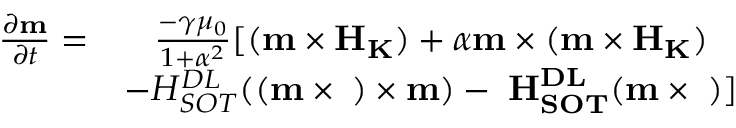Convert formula to latex. <formula><loc_0><loc_0><loc_500><loc_500>\begin{array} { c c } { \frac { { \partial } { m } } { { \partial } t } = } & { \frac { - \gamma { \mu } _ { 0 } } { 1 + { \alpha } ^ { 2 } } [ ( { m } \times { H } _ { K } ) + \alpha { m } \times ( { m } \times { H } _ { K } ) } \\ & { - H _ { S O T } ^ { D L } ( ( { m } \times { \sigma } ) \times { m } ) - \alpha H _ { S O T } ^ { D L } ( { m } \times { \sigma } ) ] } \end{array}</formula> 